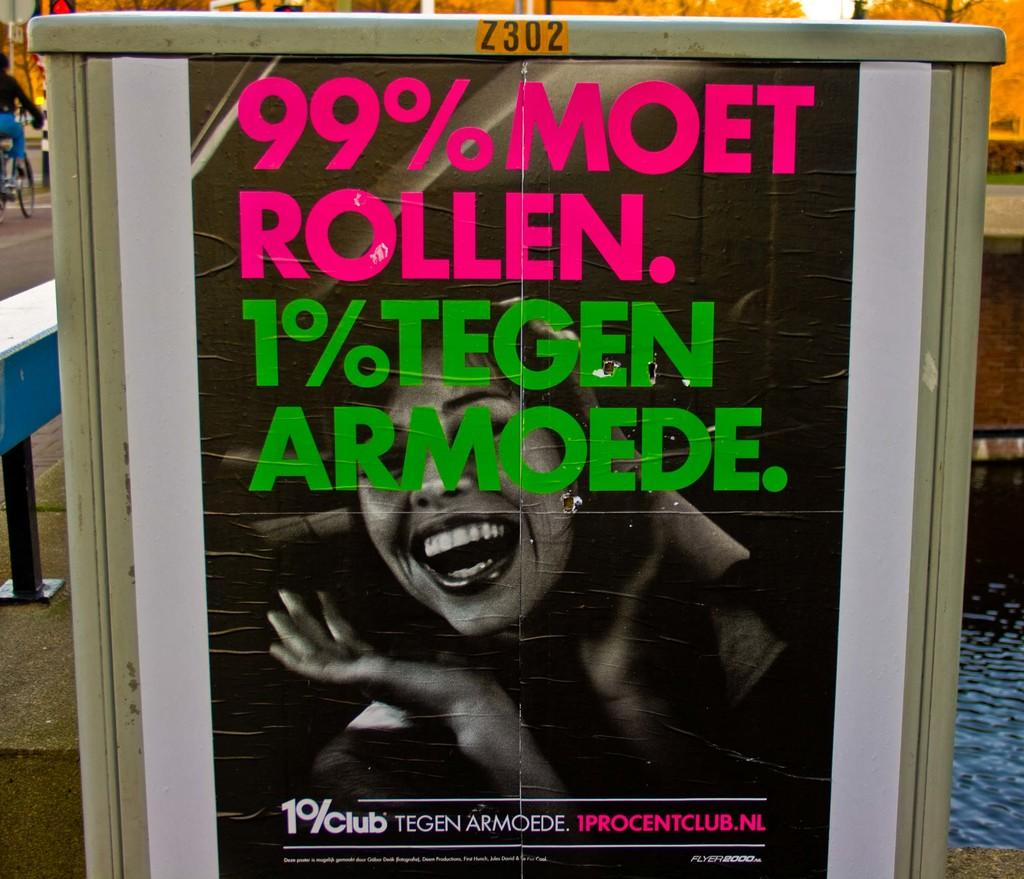What is the main subject in the center of the image? There is a poster on a board in the center of the image. What activity is being performed on the left side of the image? There is a person riding a bicycle on the left side of the image. What natural element is visible on the right side of the image? There is water visible on the right side of the image. How many gloves are being worn by the person riding the bicycle in the image? There is no mention of gloves in the image, and the person riding the bicycle is not wearing any gloves. 